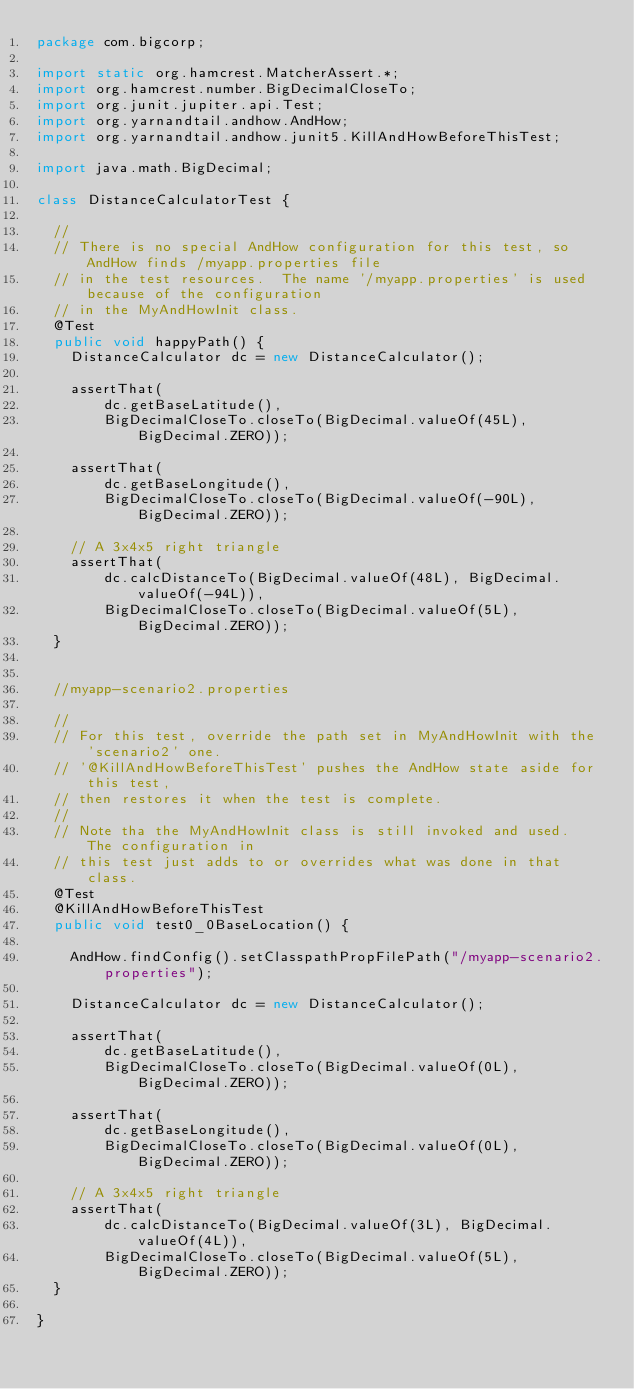Convert code to text. <code><loc_0><loc_0><loc_500><loc_500><_Java_>package com.bigcorp;

import static org.hamcrest.MatcherAssert.*;
import org.hamcrest.number.BigDecimalCloseTo;
import org.junit.jupiter.api.Test;
import org.yarnandtail.andhow.AndHow;
import org.yarnandtail.andhow.junit5.KillAndHowBeforeThisTest;

import java.math.BigDecimal;

class DistanceCalculatorTest {

	//
	// There is no special AndHow configuration for this test, so AndHow finds /myapp.properties file
	// in the test resources.  The name '/myapp.properties' is used because of the configuration
	// in the MyAndHowInit class.
	@Test
	public void happyPath() {
		DistanceCalculator dc = new DistanceCalculator();

		assertThat(
				dc.getBaseLatitude(),
				BigDecimalCloseTo.closeTo(BigDecimal.valueOf(45L), BigDecimal.ZERO));

		assertThat(
				dc.getBaseLongitude(),
				BigDecimalCloseTo.closeTo(BigDecimal.valueOf(-90L), BigDecimal.ZERO));

		// A 3x4x5 right triangle
		assertThat(
				dc.calcDistanceTo(BigDecimal.valueOf(48L), BigDecimal.valueOf(-94L)),
				BigDecimalCloseTo.closeTo(BigDecimal.valueOf(5L), BigDecimal.ZERO));
	}


	//myapp-scenario2.properties

	//
	// For this test, override the path set in MyAndHowInit with the 'scenario2' one.
	// '@KillAndHowBeforeThisTest' pushes the AndHow state aside for this test,
	// then restores it when the test is complete.
	//
	// Note tha the MyAndHowInit class is still invoked and used.  The configuration in
	// this test just adds to or overrides what was done in that class.
	@Test
	@KillAndHowBeforeThisTest
	public void test0_0BaseLocation() {

		AndHow.findConfig().setClasspathPropFilePath("/myapp-scenario2.properties");

		DistanceCalculator dc = new DistanceCalculator();

		assertThat(
				dc.getBaseLatitude(),
				BigDecimalCloseTo.closeTo(BigDecimal.valueOf(0L), BigDecimal.ZERO));

		assertThat(
				dc.getBaseLongitude(),
				BigDecimalCloseTo.closeTo(BigDecimal.valueOf(0L), BigDecimal.ZERO));

		// A 3x4x5 right triangle
		assertThat(
				dc.calcDistanceTo(BigDecimal.valueOf(3L), BigDecimal.valueOf(4L)),
				BigDecimalCloseTo.closeTo(BigDecimal.valueOf(5L), BigDecimal.ZERO));
	}

}</code> 